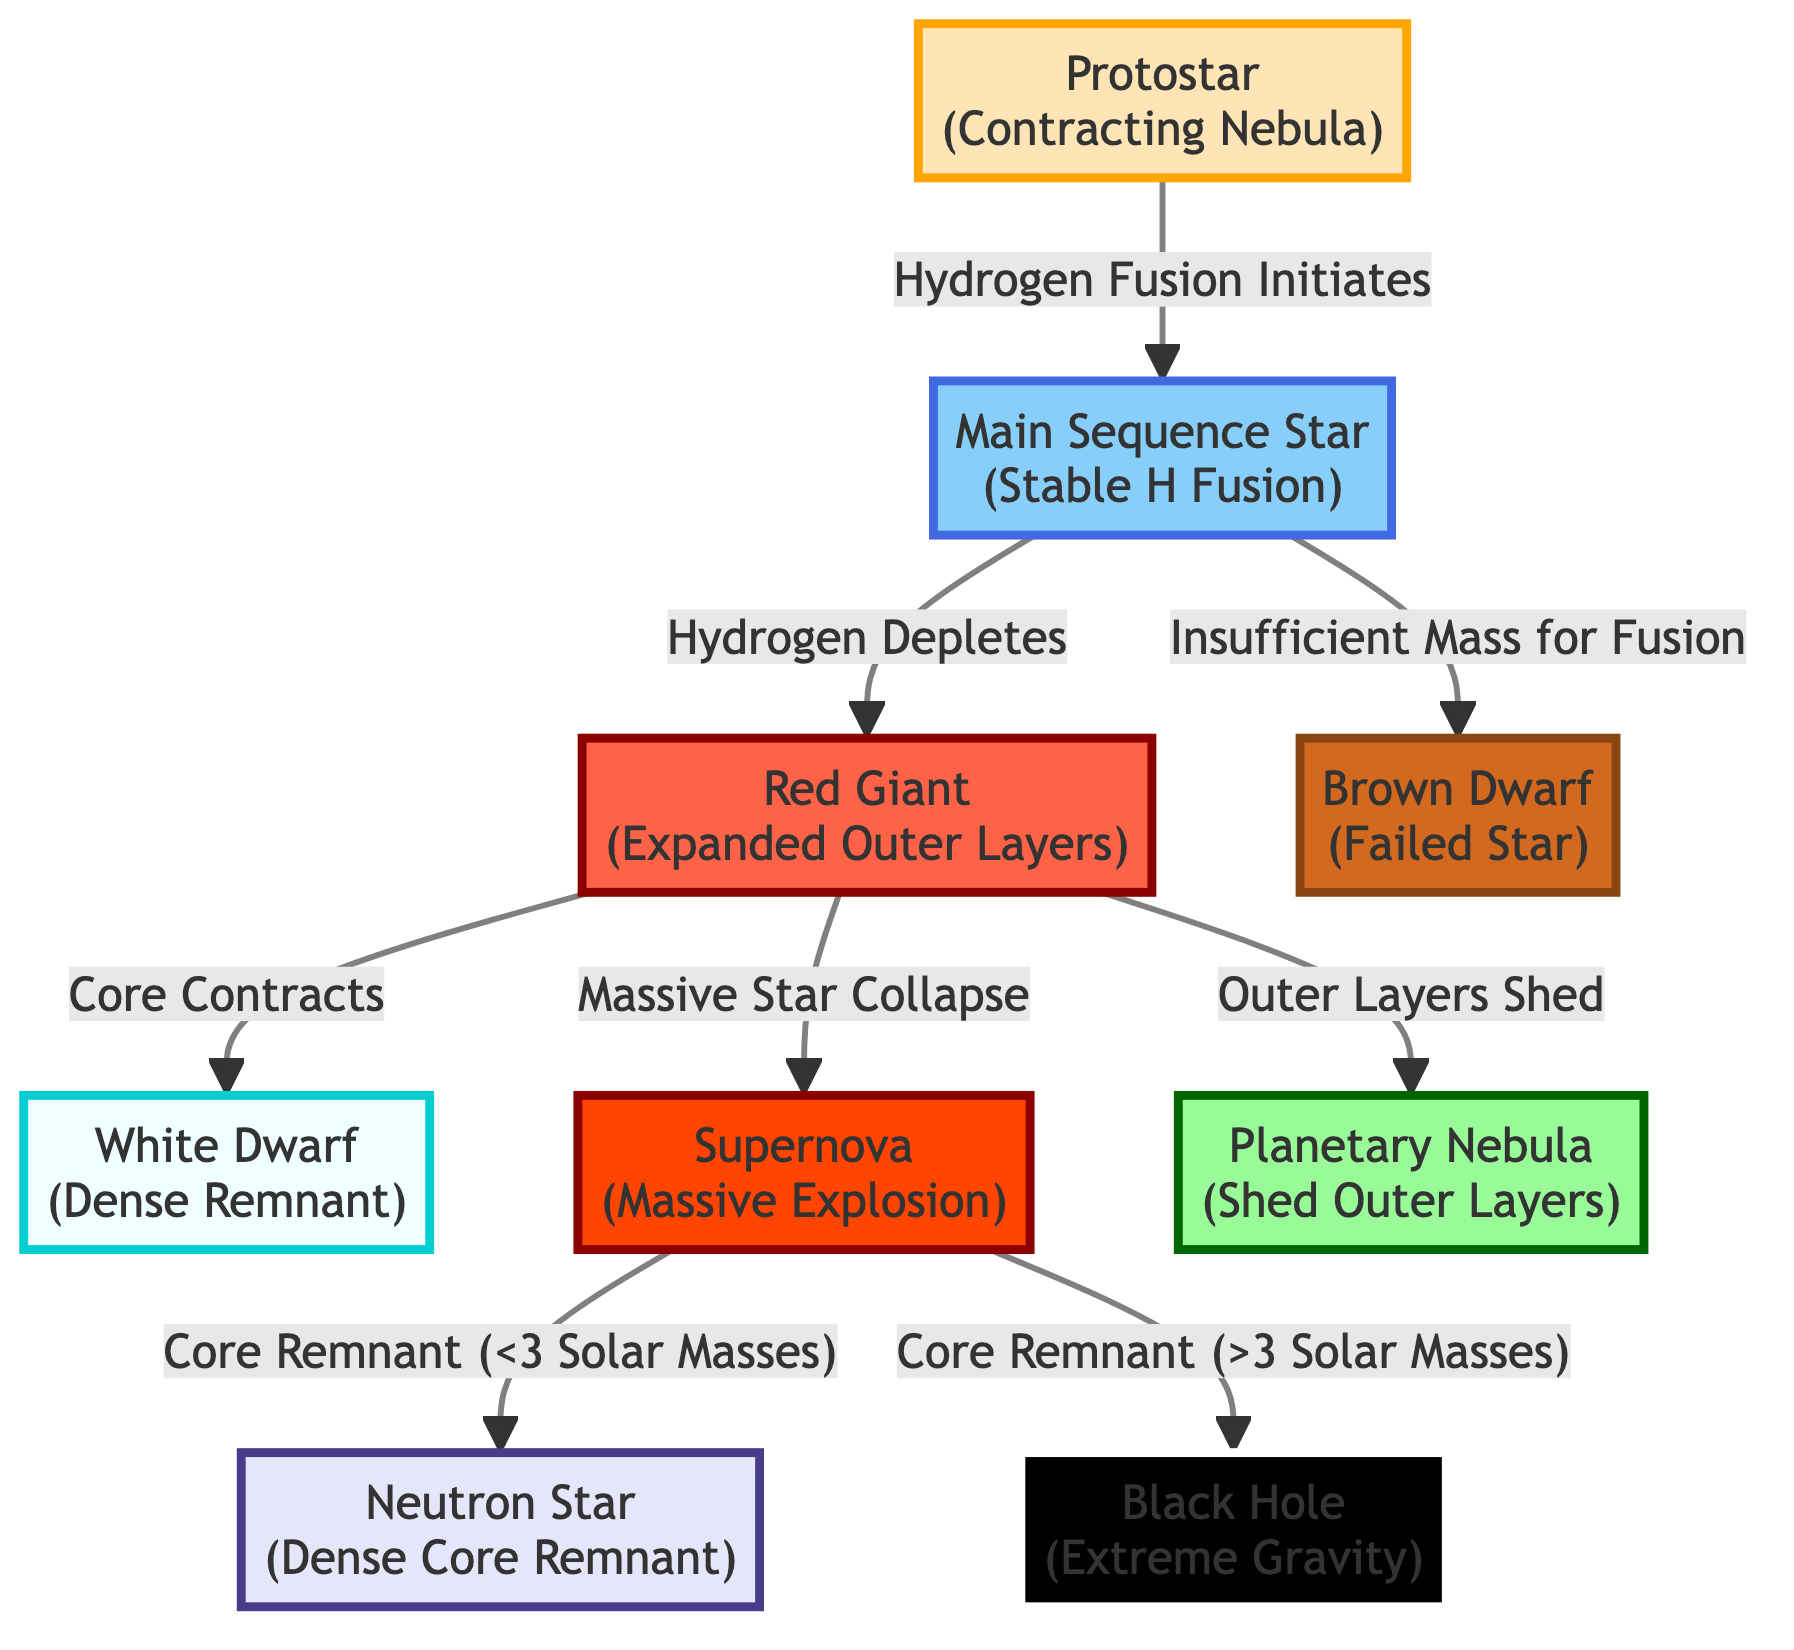What is the first stage in the evolutionary pathway of stars? The diagram begins with the node labeled "Protostar (Contracting Nebula)" as the initiation point for stellar evolution.
Answer: Protostar How many main evolutionary stages of stars are shown in the diagram? Counting the main stages, we see Protostar, Main Sequence, Red Giant, White Dwarf, Supernova, Neutron Star, Black Hole, Planetary Nebula, and Brown Dwarf. This totals to 9 distinct stages.
Answer: 9 What transition happens when hydrogen fusion initiates? The diagram shows an arrow indicating the transition from "Protostar" to "Main Sequence Star (Stable H Fusion)" upon the initiation of hydrogen fusion.
Answer: Main Sequence Star What happens to a red giant as it evolves? The diagram indicates two key transitions for a red giant: it sheds its outer layers to become a Planetary Nebula and contracts its core to form a White Dwarf.
Answer: Planetary Nebula and White Dwarf What is the fate of a massive star after a supernova? The diagram presents two outcomes after a supernova depending on the core mass: it can become a Neutron Star if it is less than 3 solar masses or a Black Hole if it exceeds 3 solar masses.
Answer: Neutron Star and Black Hole What type of star is characterized as a 'failed star'? The diagram clearly labels "Brown Dwarf" specifically as a type of celestial object that did not develop into a fully functional star.
Answer: Brown Dwarf What signifies the transition from a main sequence star to a brown dwarf? The diagram indicates that the transition occurs when a main sequence star lacks sufficient mass for continued fusion. This node connects to the "Brown Dwarf."
Answer: Insufficient Mass for Fusion Which stage includes the phrase "Massive Explosion"? The diagram uses this phrase to describe the "Supernova" stage, highlighting the dramatic end of a massive star's life cycle.
Answer: Supernova What relationship does a protostar have with the main sequence? They are sequentially connected in the diagram, where a protostar evolves into a main sequence star once hydrogen fusion begins, establishing a direct evolutionary link.
Answer: Hydrogen Fusion Initiates 